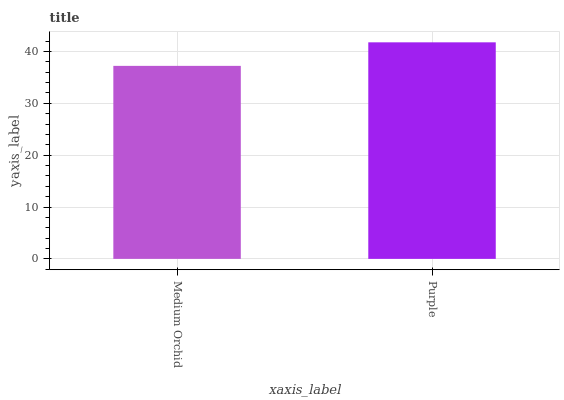Is Medium Orchid the minimum?
Answer yes or no. Yes. Is Purple the maximum?
Answer yes or no. Yes. Is Purple the minimum?
Answer yes or no. No. Is Purple greater than Medium Orchid?
Answer yes or no. Yes. Is Medium Orchid less than Purple?
Answer yes or no. Yes. Is Medium Orchid greater than Purple?
Answer yes or no. No. Is Purple less than Medium Orchid?
Answer yes or no. No. Is Purple the high median?
Answer yes or no. Yes. Is Medium Orchid the low median?
Answer yes or no. Yes. Is Medium Orchid the high median?
Answer yes or no. No. Is Purple the low median?
Answer yes or no. No. 